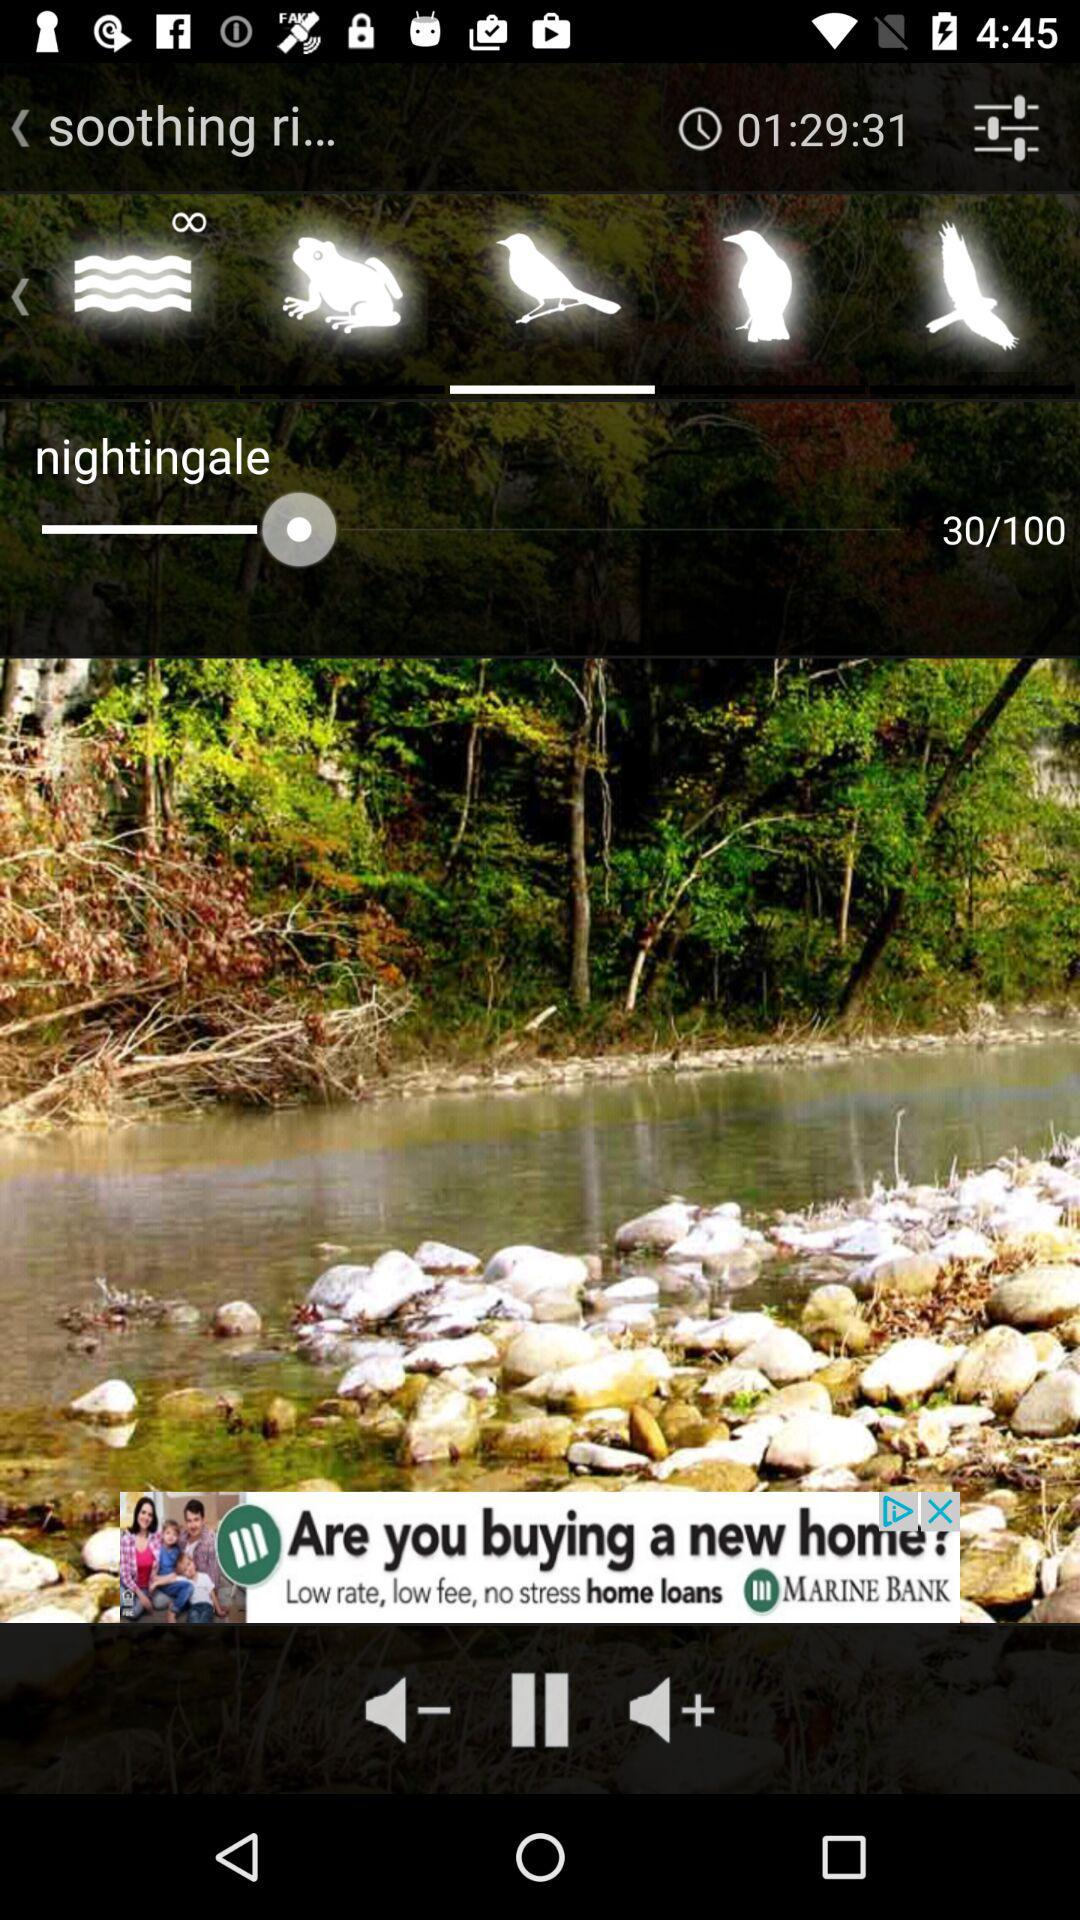How long is the soothing ringtone? The soothing ringtone is 1 hour 29 minutes 31 seconds long. 